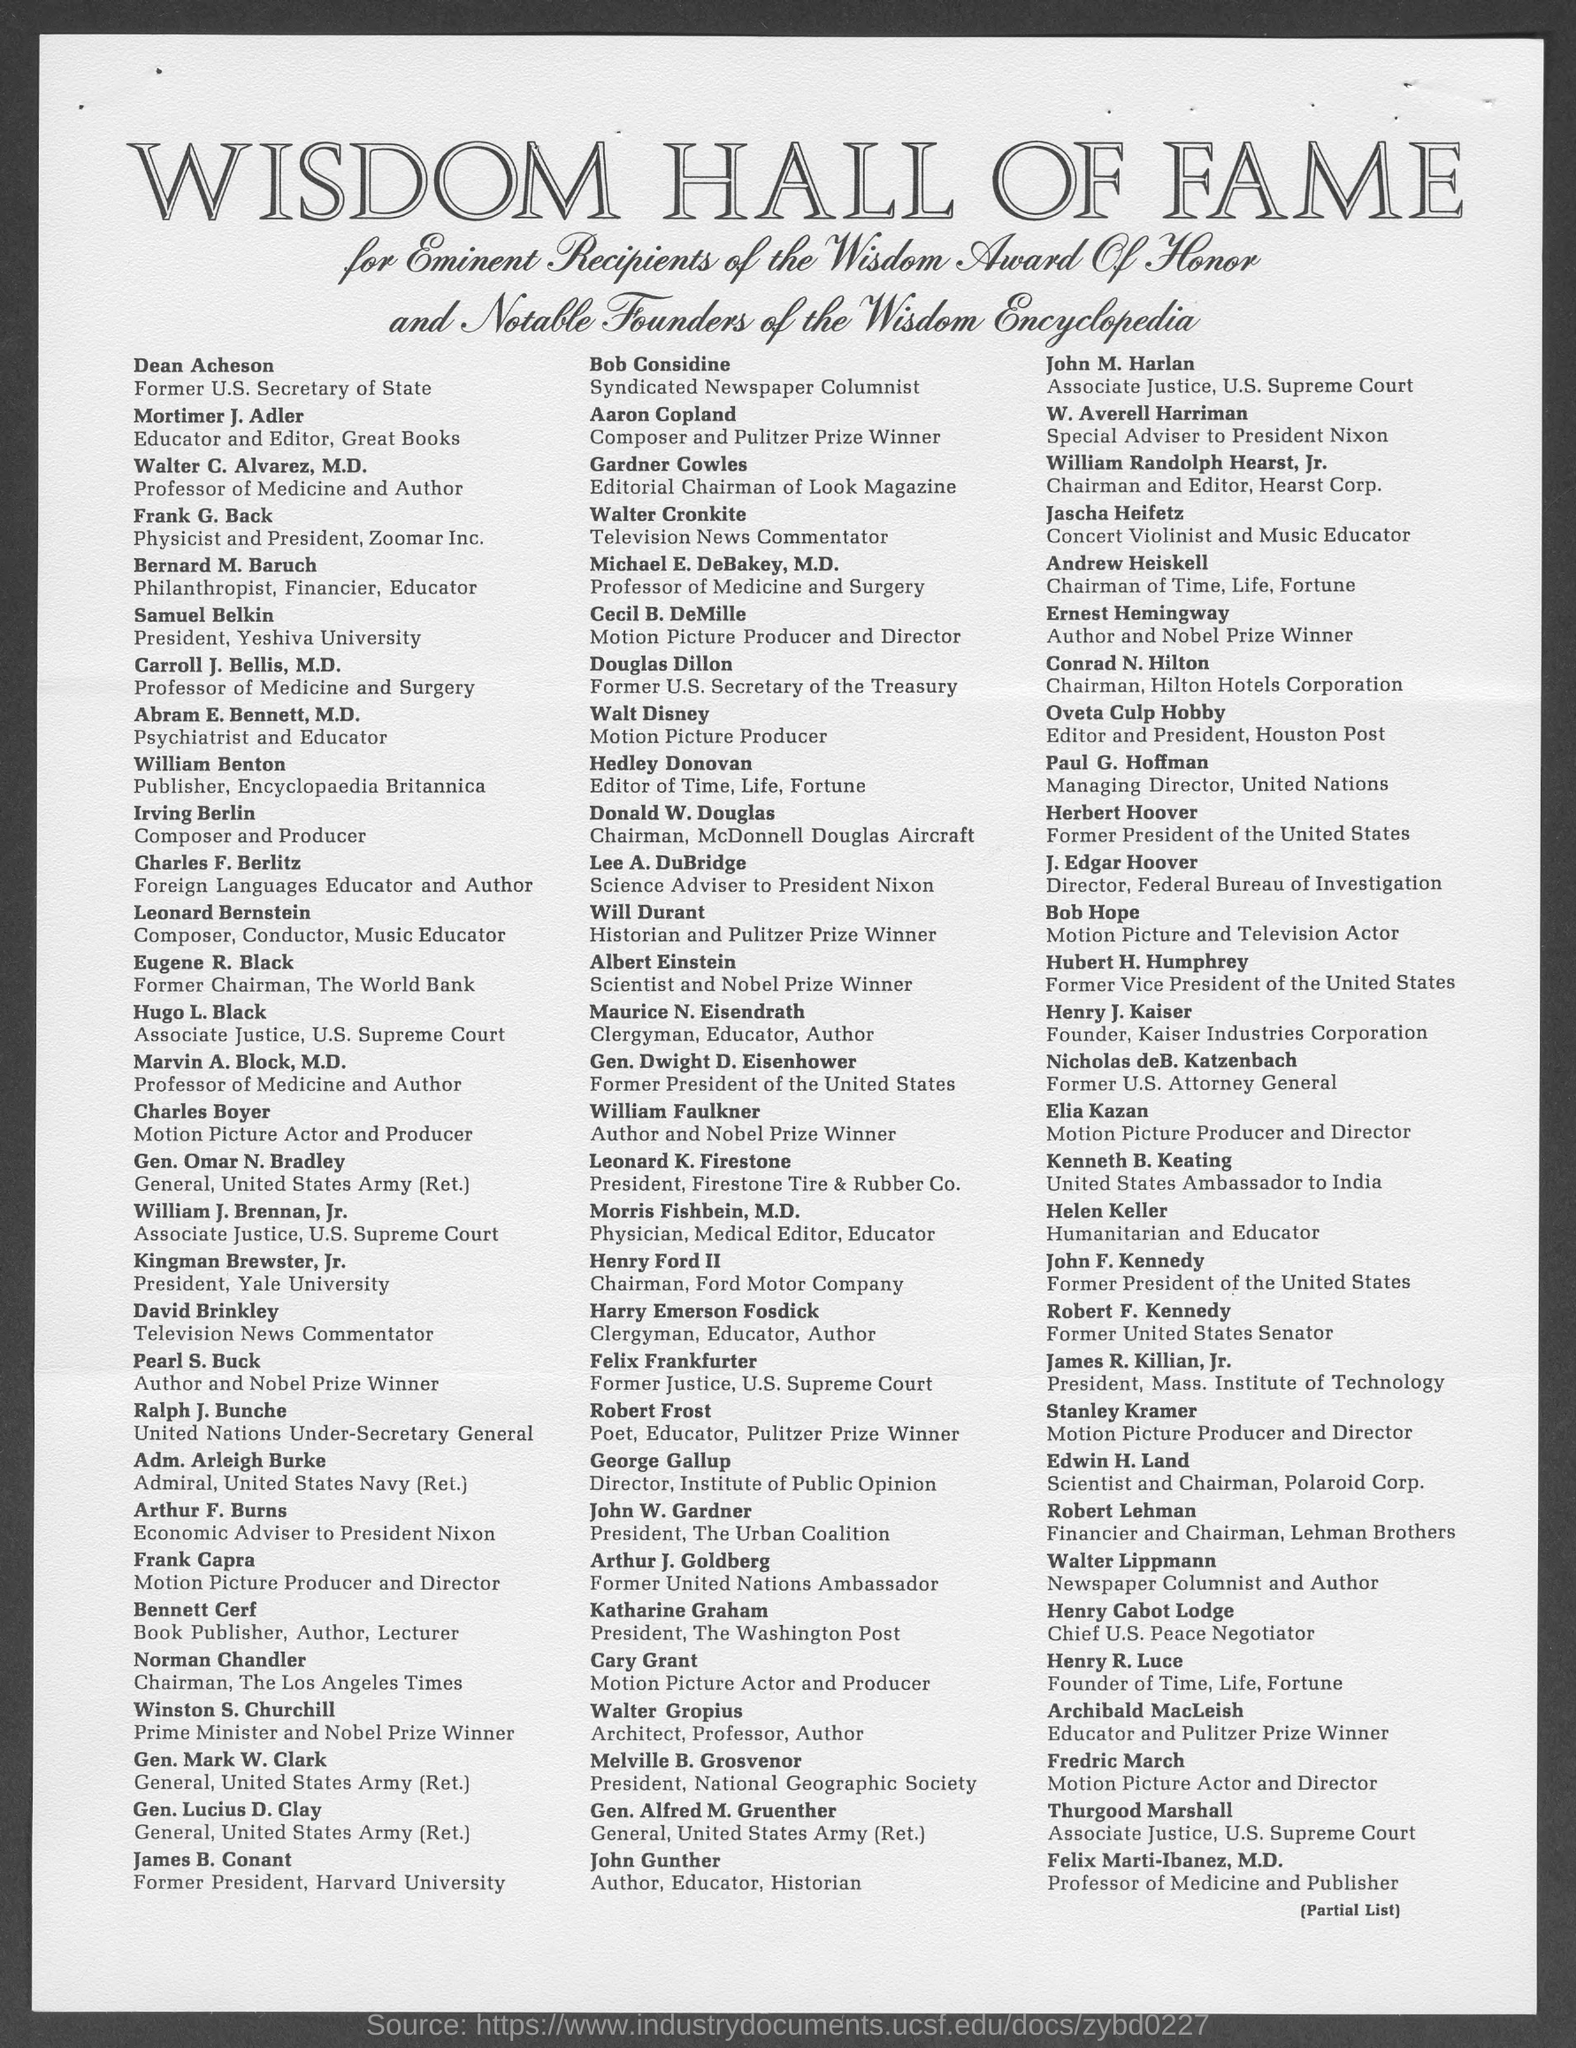Specify some key components in this picture. Katharine Graham, as stated in the given page, held the designation of President of The Washington Post. The given page lists Paul G. Hoffman as having the designation of Managing Director of the United Nations. According to the given page, Frank G. Back is designated as a physicist and the president of Zoomar Inc. Dean Acheson was designated as former U.S. Secretary of State, as mentioned on the given page. George Gallup is described as the Director of the Institute of Public Opinion on the given page. 